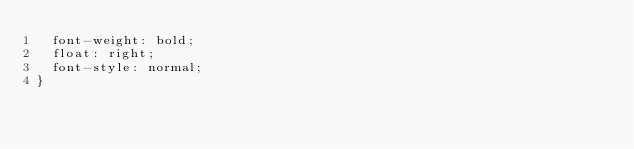<code> <loc_0><loc_0><loc_500><loc_500><_CSS_>  font-weight: bold;
  float: right;
  font-style: normal;
}
</code> 